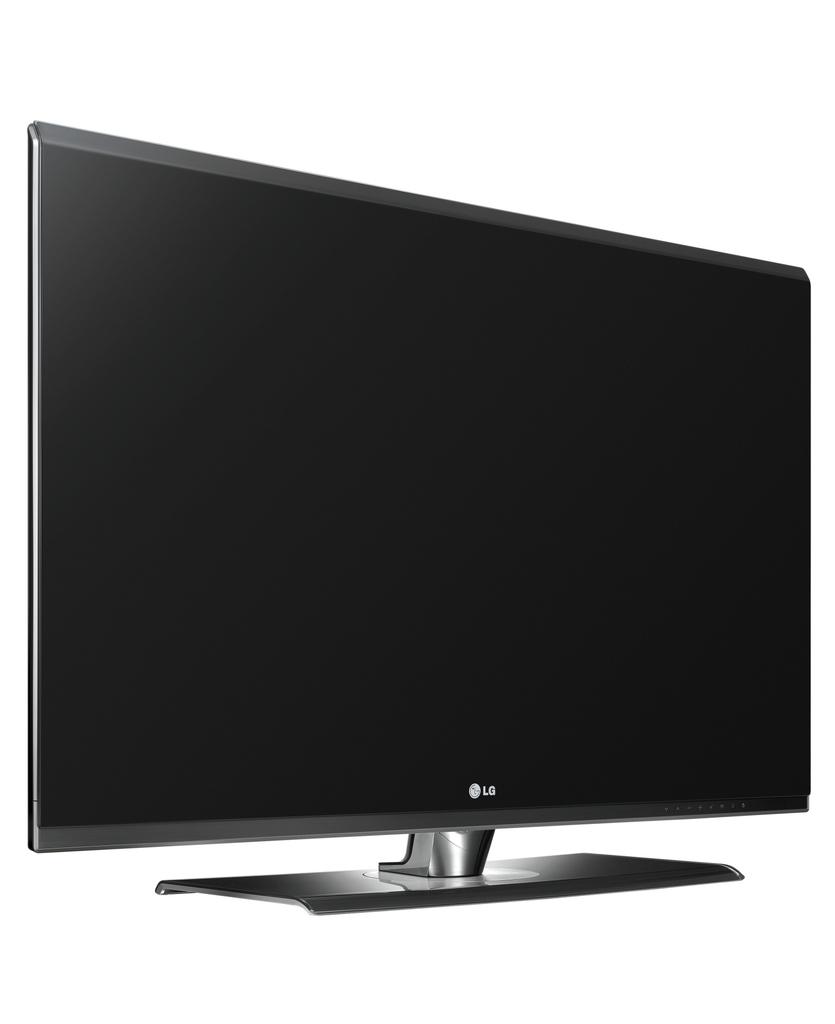What brand of monitor / tv is this?
Give a very brief answer. Lg. 